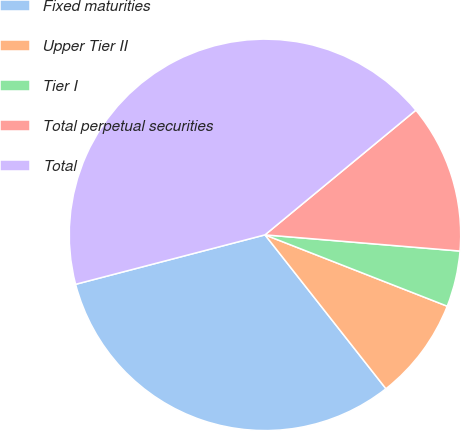Convert chart. <chart><loc_0><loc_0><loc_500><loc_500><pie_chart><fcel>Fixed maturities<fcel>Upper Tier II<fcel>Tier I<fcel>Total perpetual securities<fcel>Total<nl><fcel>31.54%<fcel>8.46%<fcel>4.62%<fcel>12.31%<fcel>43.08%<nl></chart> 